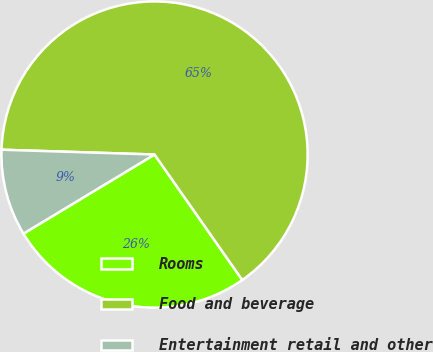Convert chart to OTSL. <chart><loc_0><loc_0><loc_500><loc_500><pie_chart><fcel>Rooms<fcel>Food and beverage<fcel>Entertainment retail and other<nl><fcel>26.07%<fcel>64.78%<fcel>9.14%<nl></chart> 